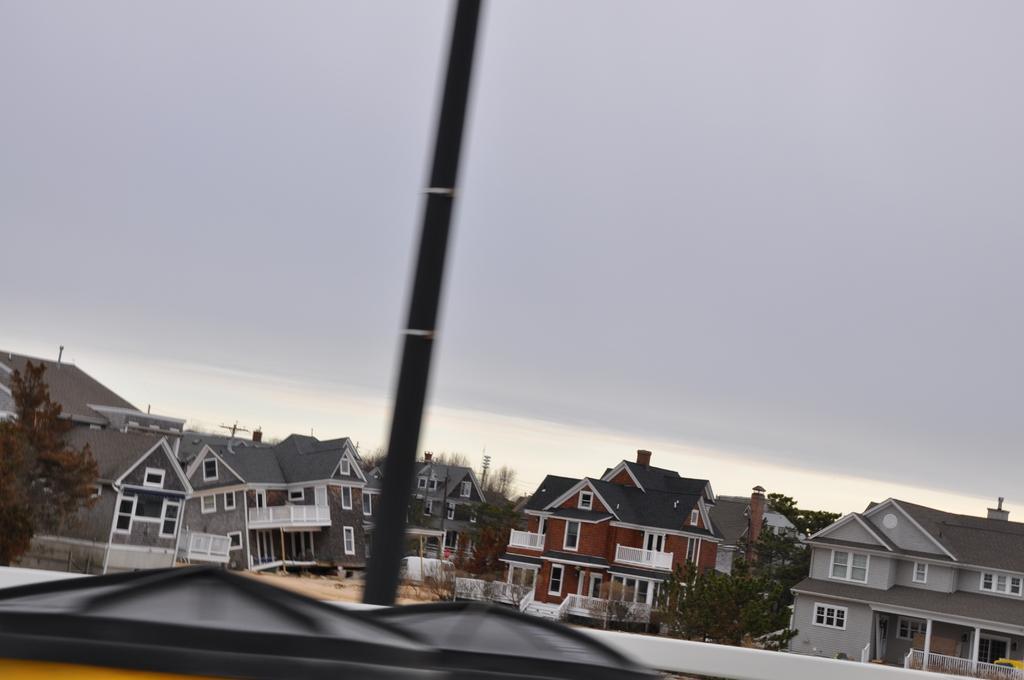Can you describe this image briefly? In the foreground of this image, there is a black object and a pole like an object is behind it. In the background, there are buildings and a building is leaning on the left side of the image. On the top, there is the sky and the cloud. 